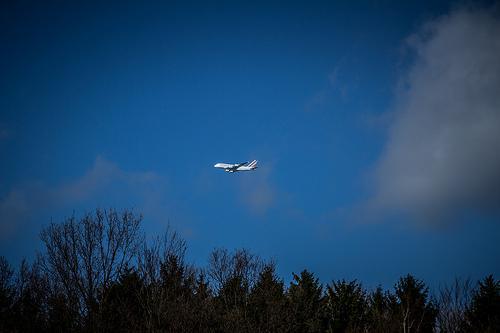How many planes are there?
Give a very brief answer. 1. 